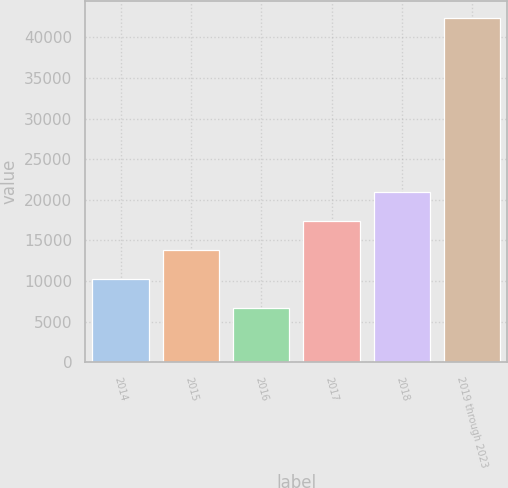<chart> <loc_0><loc_0><loc_500><loc_500><bar_chart><fcel>2014<fcel>2015<fcel>2016<fcel>2017<fcel>2018<fcel>2019 through 2023<nl><fcel>10290.1<fcel>13857.2<fcel>6723<fcel>17424.3<fcel>20991.4<fcel>42394<nl></chart> 